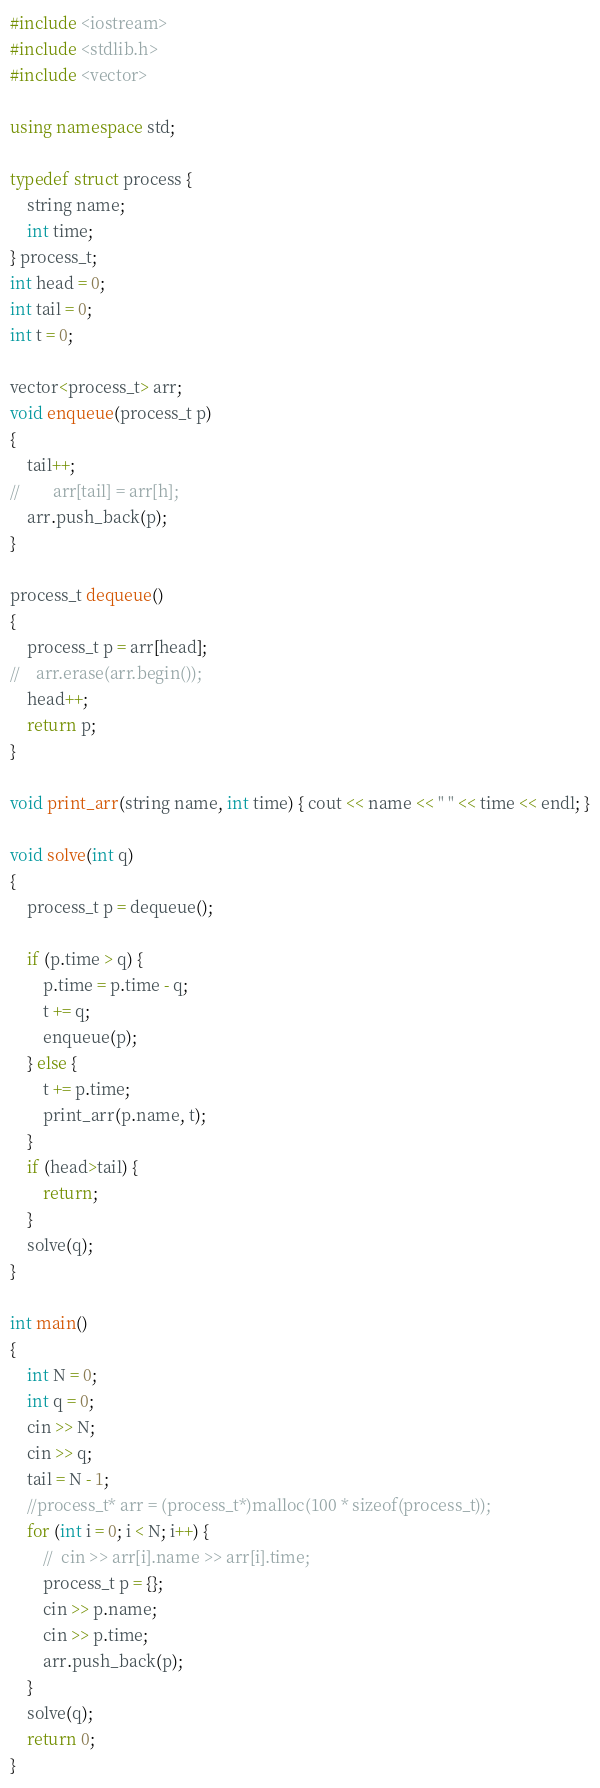Convert code to text. <code><loc_0><loc_0><loc_500><loc_500><_C++_>#include <iostream>
#include <stdlib.h>
#include <vector>

using namespace std;

typedef struct process {
    string name;
    int time;
} process_t;
int head = 0;
int tail = 0;
int t = 0;

vector<process_t> arr;
void enqueue(process_t p)
{
    tail++;
//        arr[tail] = arr[h];
    arr.push_back(p);
}

process_t dequeue()
{
    process_t p = arr[head];
//    arr.erase(arr.begin());
    head++;
    return p;
}

void print_arr(string name, int time) { cout << name << " " << time << endl; }

void solve(int q)
{
    process_t p = dequeue();
    
    if (p.time > q) {
        p.time = p.time - q;
        t += q;
        enqueue(p);
    } else {
        t += p.time;
        print_arr(p.name, t);
    }
    if (head>tail) {
        return;
    }
    solve(q);
}

int main()
{
    int N = 0;
    int q = 0;
    cin >> N;
    cin >> q;
    tail = N - 1;
    //process_t* arr = (process_t*)malloc(100 * sizeof(process_t));
    for (int i = 0; i < N; i++) {
        //	cin >> arr[i].name >> arr[i].time;
        process_t p = {};
        cin >> p.name;
        cin >> p.time;
        arr.push_back(p);
    }
    solve(q);
    return 0;
}</code> 